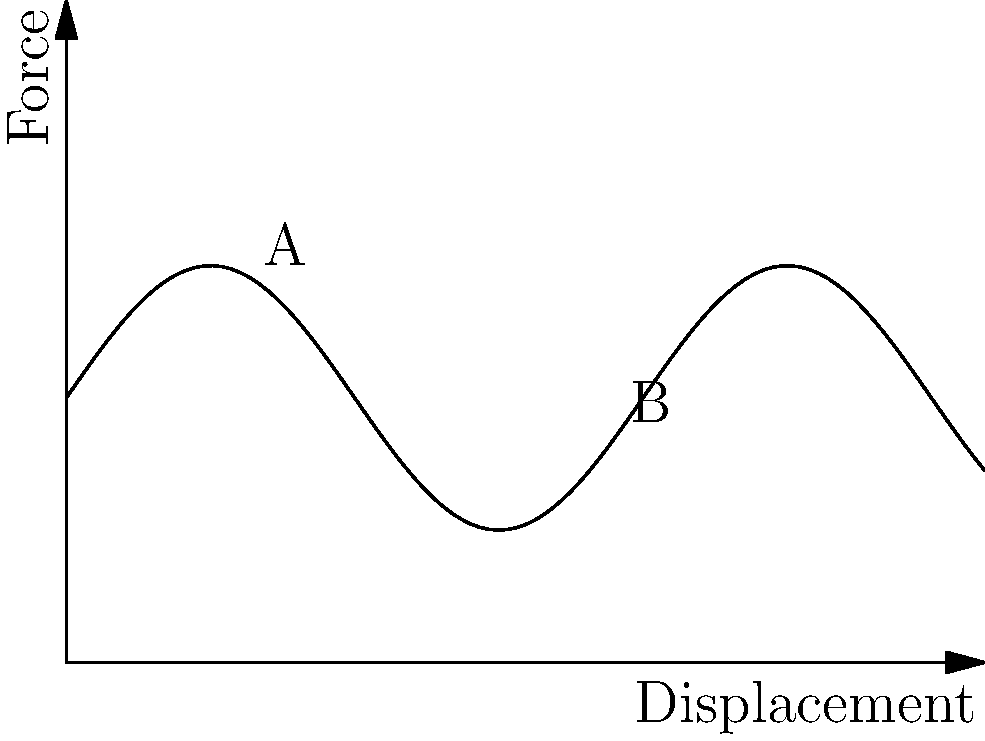In O. Henry's short story "The Last Leaf," an artist's masterpiece saves a life. Similarly, in mechanical engineering, understanding graphs can be crucial. The force-displacement curve for a spring-mass-damper system under harmonic excitation is shown above. What does the difference in force between points A and B primarily represent? To understand the force-displacement curve for a spring-mass-damper system under harmonic excitation, let's break it down step-by-step:

1. The curve represents the relationship between force and displacement in the system.

2. In a spring-mass-damper system under harmonic excitation:
   - The spring provides a restoring force proportional to displacement.
   - The damper provides a force proportional to velocity.
   - The mass provides inertia.
   - The harmonic excitation provides an external forcing function.

3. The sinusoidal shape of the curve indicates the system's response to harmonic excitation.

4. Points A and B are at different phases of the oscillation cycle.

5. The vertical distance between A and B represents a difference in force at two different displacements.

6. This force difference is primarily due to the spring's restoring force, as it changes with displacement according to Hooke's Law: $F = -kx$, where $k$ is the spring constant and $x$ is the displacement.

7. The damping force and inertial force also contribute to the total force, but they are typically smaller in magnitude compared to the spring force in a stable system.

Therefore, the primary component of the force difference between A and B is the change in the spring's restoring force due to the difference in displacement.
Answer: Spring's restoring force change 